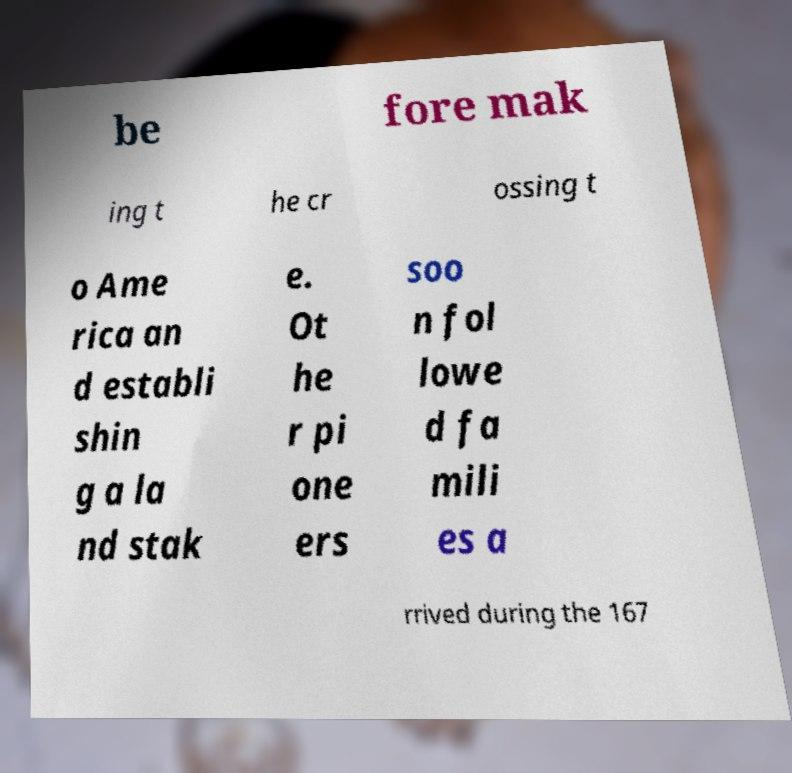Could you extract and type out the text from this image? be fore mak ing t he cr ossing t o Ame rica an d establi shin g a la nd stak e. Ot he r pi one ers soo n fol lowe d fa mili es a rrived during the 167 